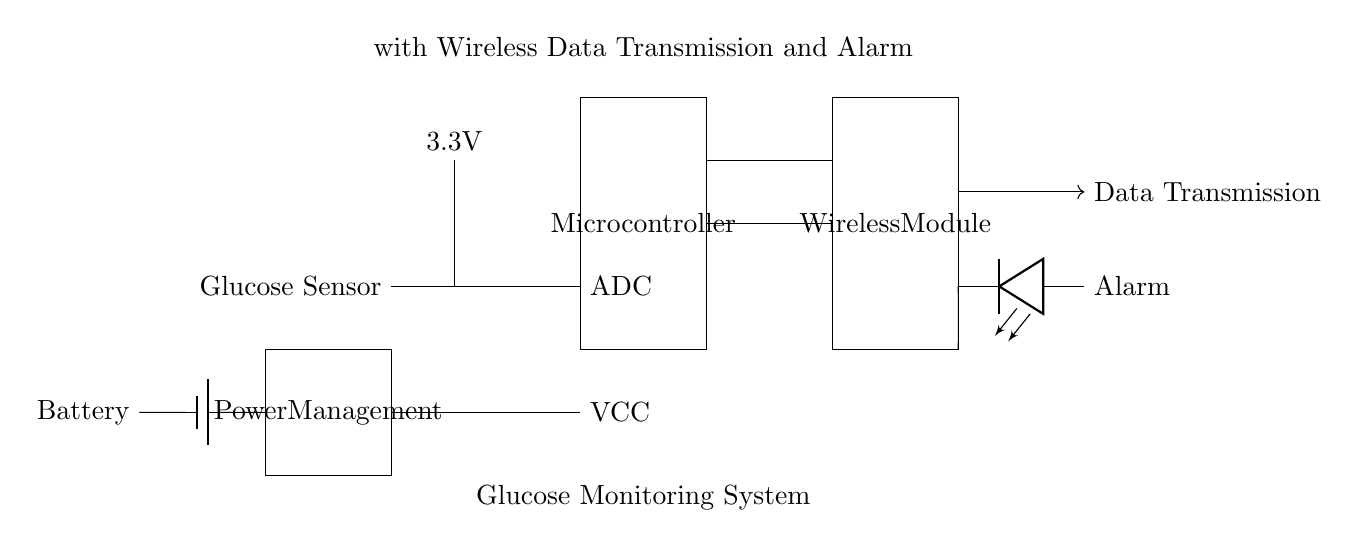What is the main function of the glucose sensor in this circuit? The glucose sensor detects glucose levels in the blood and sends the signal to the microcontroller for processing.
Answer: Detect glucose levels What operates at a voltage of 3.3 volts in this system? The glucose sensor is connected to a power supply that provides a voltage of 3.3 volts, as indicated in the diagram.
Answer: Glucose sensor What type of component is represented by the block labeled "Microcontroller"? The microcontroller is a processing unit that interprets the data from the glucose sensor using an Analog-to-Digital Converter (ADC).
Answer: Processing unit How does data transmission occur in this glucose monitoring system? Data is transmitted wirelessly from the microcontroller to the "Wireless Module," which handles communication, indicated by the arrow labeled "Data Transmission."
Answer: Wireless What is the purpose of the alarm circuit in this glucose monitoring system? The alarm circuit is designed to alert users when the glucose levels fall outside of a predefined range based on data processed by the microcontroller.
Answer: Alert for glucose levels What component is responsible for providing power to the entire circuit? The battery supplies electrical power to the glucose monitoring system, indicated by the block labeled "Battery" connected to the power management section.
Answer: Battery What role does the Analog-to-Digital Converter play in this circuit? The ADC converts the analog signal from the glucose sensor into a digital signal for the microcontroller to process, enabling data interpretation.
Answer: Converts signals 